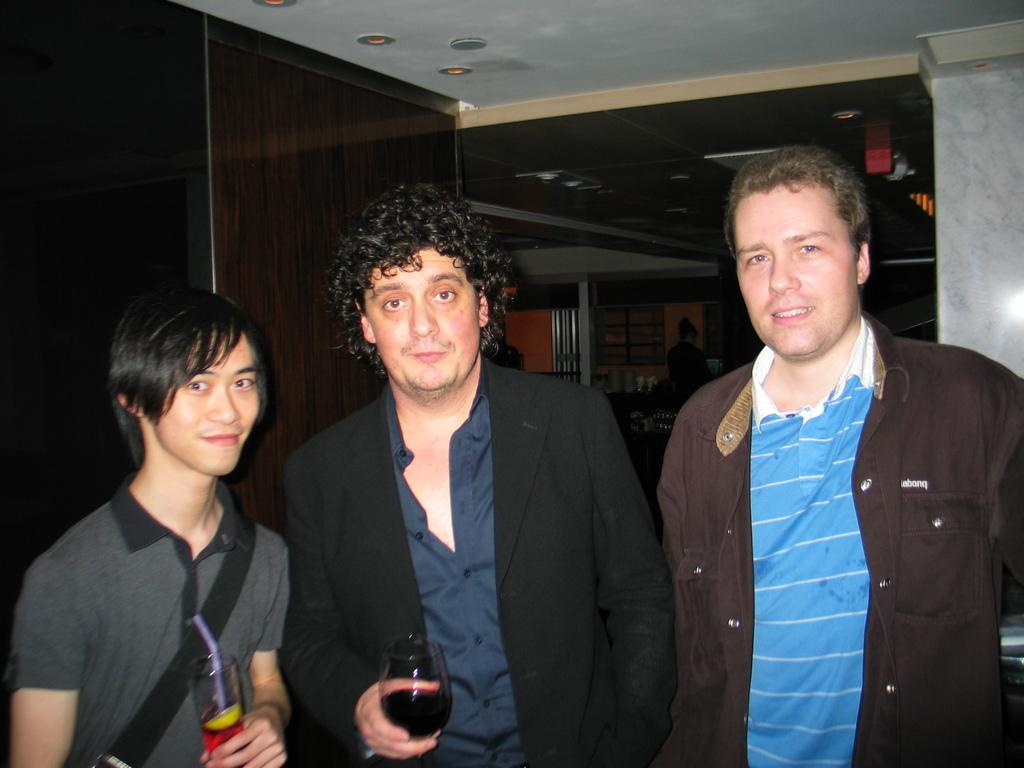How many people are in the image? There are three people in the image. What are the people doing in the image? The people are smiling in the image. What are two of the people holding in the image? Two of the people are holding glasses with liquid in the image. What can be seen in the background of the image? There is a pillar, a wall, some objects, and lights visible in the background of the image. What type of silk is being used by the lawyer in the image? There is no lawyer or silk present in the image. How does the coach instruct the players in the image? There is no coach or players present in the image. 